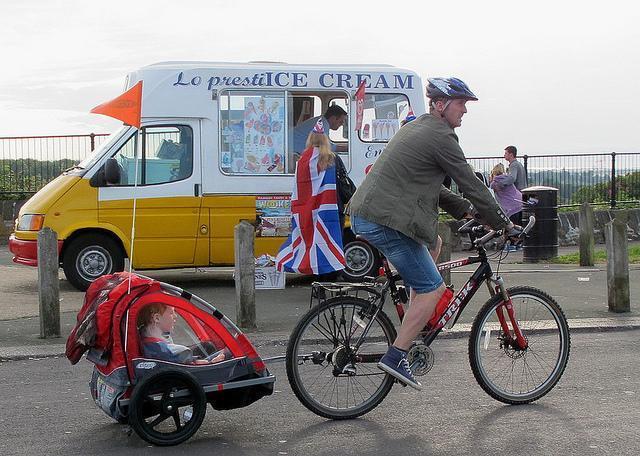How many boats are in the water?
Give a very brief answer. 0. 